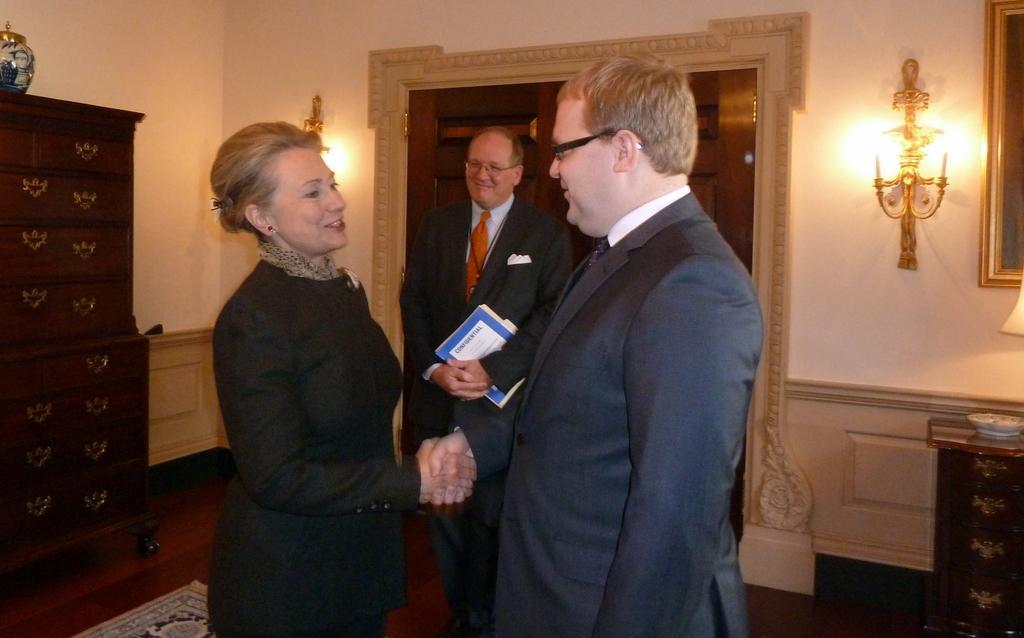Describe this image in one or two sentences. In this image there are three persons standing at middle of this image. There is a lamp at right side of this image. There is a bowl in white color kept at right side of this image. there is an object placed at left side of this image. there is one lamp at left side of this image. There is a wall in the background. The right side person is wearing white color shirt and black color blazer and the middle person is also wearing white color shirt and black color blazer and holding some books and there is one women at left side is smiling and wearing black color dress at left side of this image. there is one photo frame at top right corner of this image. 